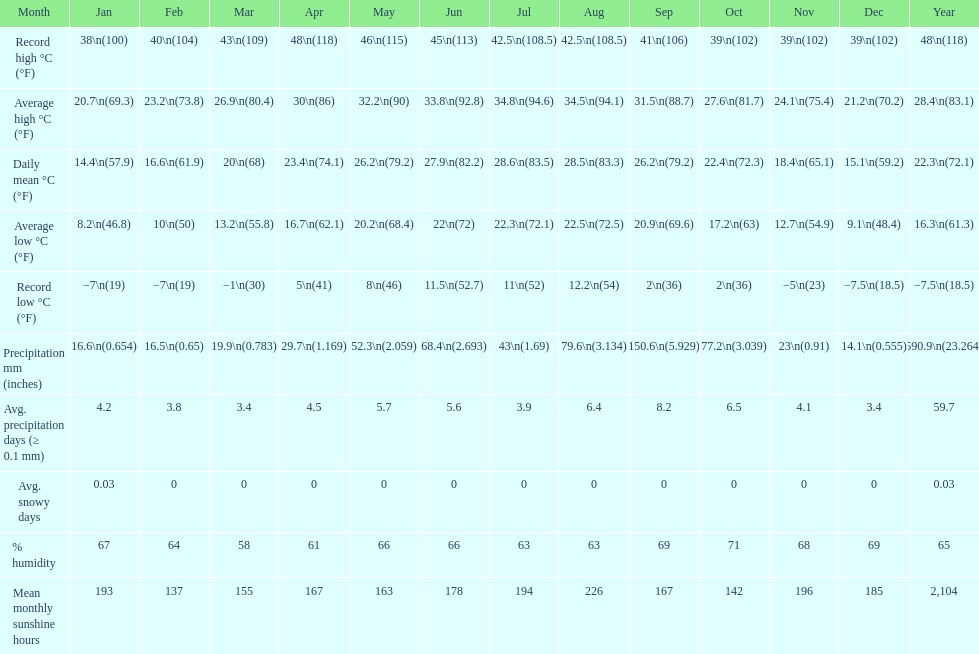Does december or january have more snow days? January. 